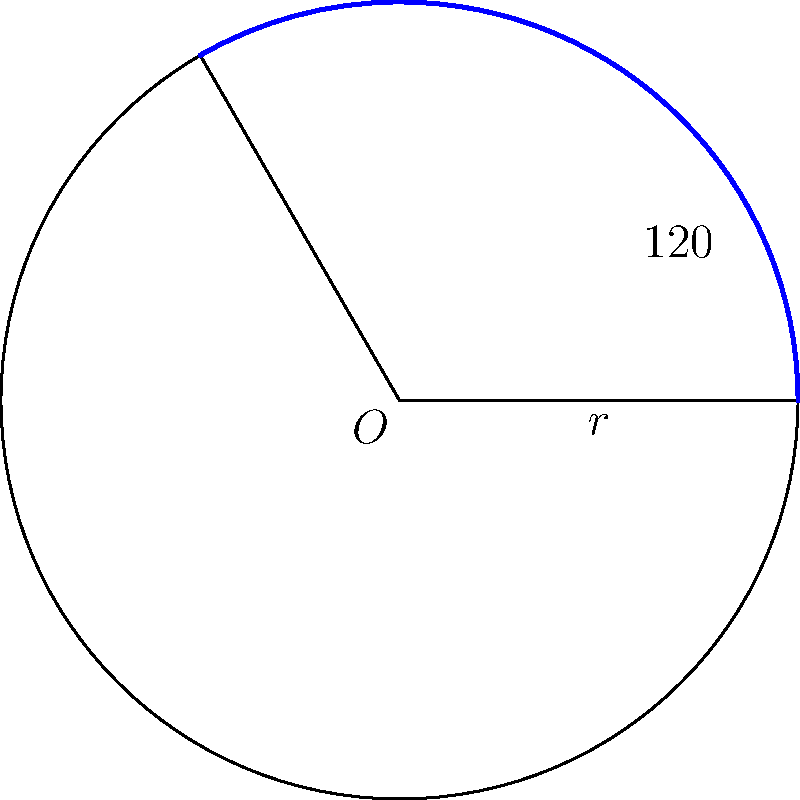As a product manager working on improving your product's predictive capabilities, you're analyzing circular data patterns. Given a circular sector with a central angle of 120° and a radius of 5 units, calculate the area of this sector. How might this calculation method be applied to predict user engagement patterns in your product? To calculate the area of a circular sector, we can follow these steps:

1) The formula for the area of a circular sector is:

   $A = \frac{\theta}{360°} \pi r^2$

   Where $A$ is the area, $\theta$ is the central angle in degrees, and $r$ is the radius.

2) We're given:
   $\theta = 120°$
   $r = 5$ units

3) Let's substitute these values into our formula:

   $A = \frac{120°}{360°} \pi (5)^2$

4) Simplify:
   $A = \frac{1}{3} \pi (25)$
   $A = \frac{25\pi}{3}$

5) If we wanted to calculate this numerically, we could use $\pi \approx 3.14159$:

   $A \approx \frac{25 * 3.14159}{3} \approx 26.18$ square units

This calculation method could be applied to predict user engagement patterns by considering the circular sector as a representation of user activity over time. The central angle could represent a time period, and the area could correspond to the level of user engagement. By analyzing how the area changes with different time periods, you could predict future engagement trends and optimize your product accordingly.
Answer: $\frac{25\pi}{3}$ square units 